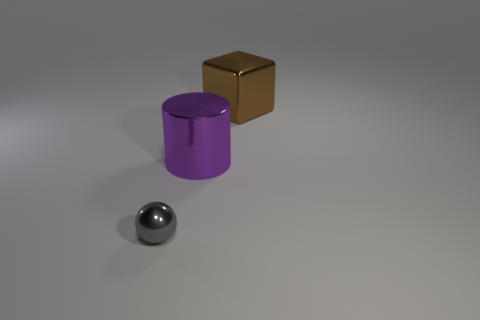Is there any other thing that has the same shape as the large brown metal thing?
Ensure brevity in your answer.  No. The big object that is in front of the shiny object behind the big purple metallic object is made of what material?
Your response must be concise. Metal. There is a thing that is in front of the purple metal cylinder; is it the same size as the cylinder?
Your answer should be very brief. No. How many matte things are either yellow cylinders or blocks?
Provide a succinct answer. 0. The object that is behind the small shiny object and in front of the cube is made of what material?
Offer a very short reply. Metal. What is the shape of the large purple shiny object?
Your answer should be compact. Cylinder. How many objects are big purple shiny cylinders or big objects that are on the left side of the brown block?
Your response must be concise. 1. Do the object that is behind the big purple metal thing and the tiny shiny ball have the same color?
Give a very brief answer. No. There is a big object in front of the big metal block; what is its material?
Make the answer very short. Metal. What size is the metal ball?
Offer a very short reply. Small. 